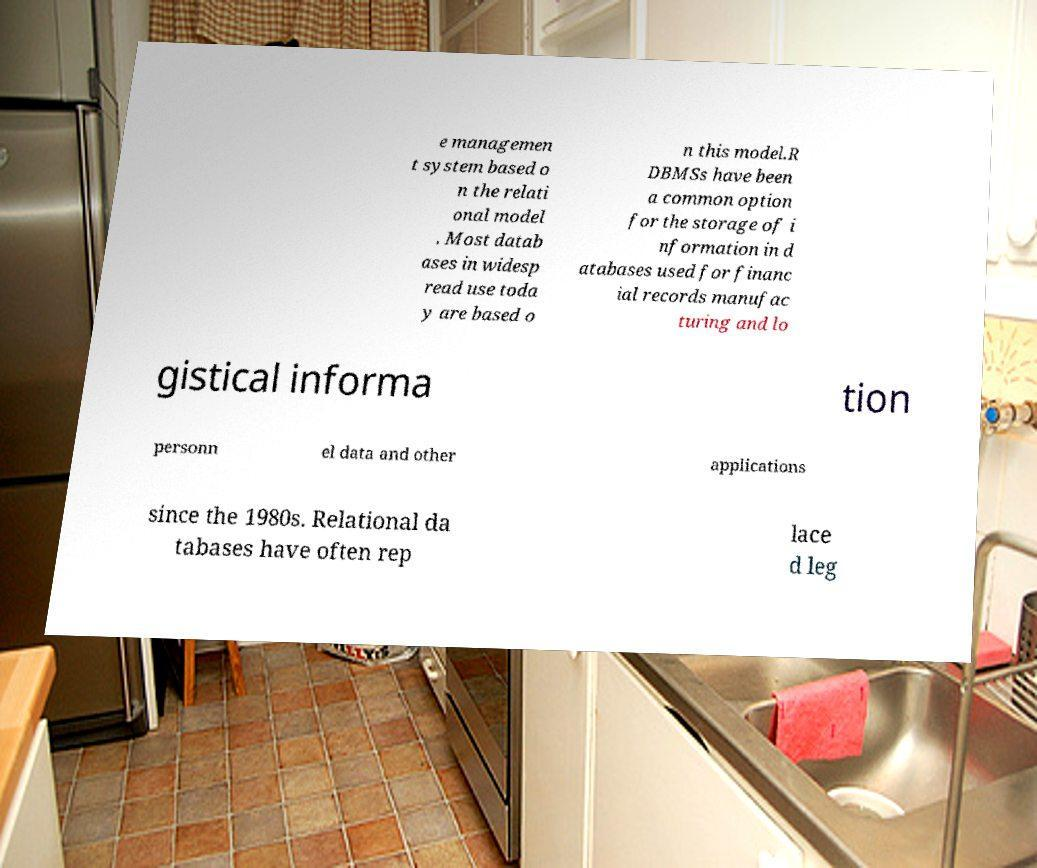I need the written content from this picture converted into text. Can you do that? e managemen t system based o n the relati onal model . Most datab ases in widesp read use toda y are based o n this model.R DBMSs have been a common option for the storage of i nformation in d atabases used for financ ial records manufac turing and lo gistical informa tion personn el data and other applications since the 1980s. Relational da tabases have often rep lace d leg 